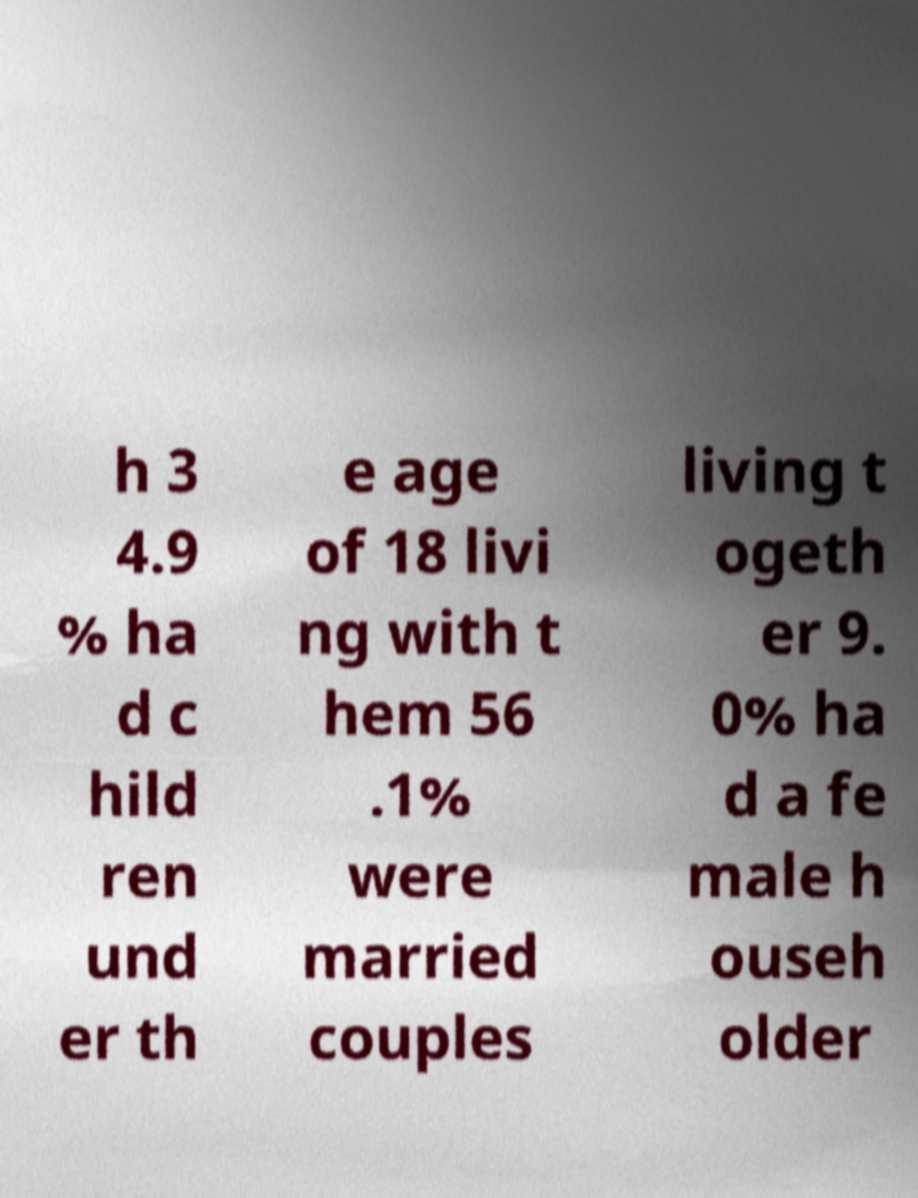For documentation purposes, I need the text within this image transcribed. Could you provide that? h 3 4.9 % ha d c hild ren und er th e age of 18 livi ng with t hem 56 .1% were married couples living t ogeth er 9. 0% ha d a fe male h ouseh older 